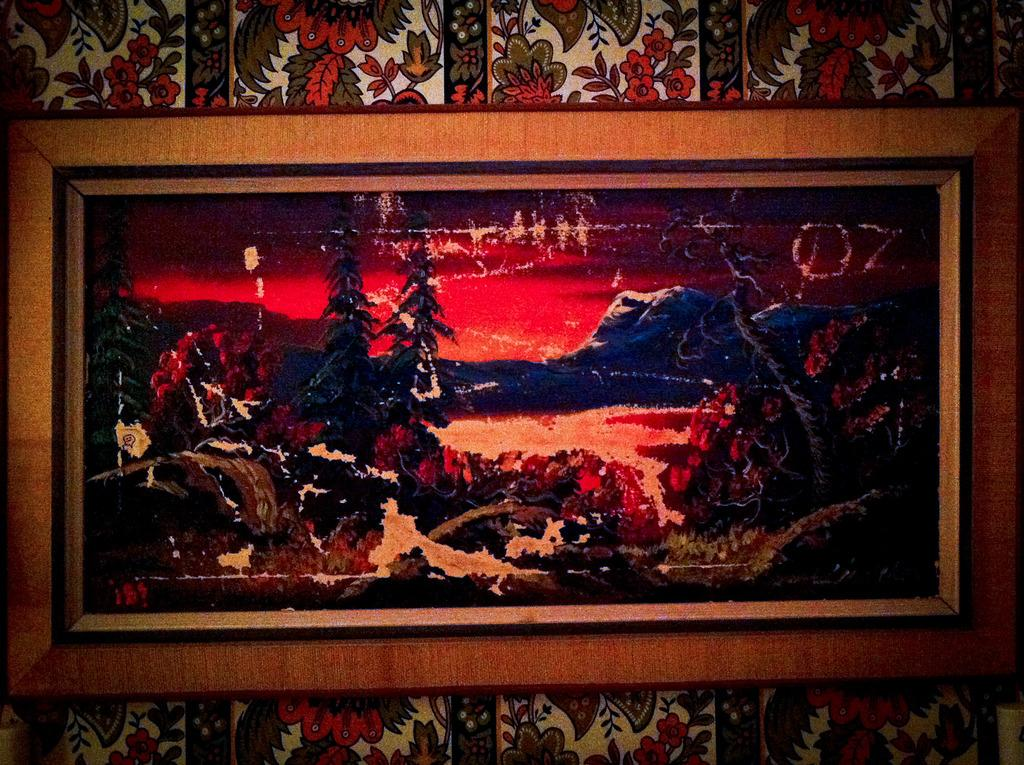What object can be seen in the image that is typically used for displaying photos? There is a photo frame in the image. Where is the photo frame located in the image? The photo frame is present on a wall. How many passengers are visible in the image? There are no passengers present in the image; it only features a photo frame on a wall. What type of base is supporting the photo frame in the image? The photo frame is mounted on a wall, so there is no separate base visible in the image. 